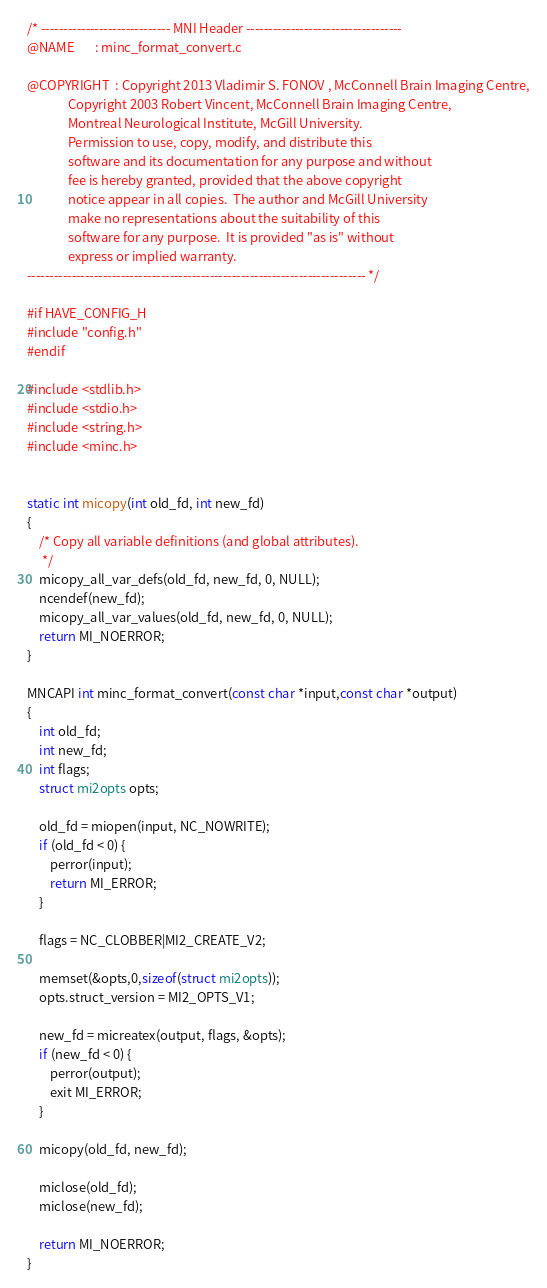Convert code to text. <code><loc_0><loc_0><loc_500><loc_500><_C_>/* ----------------------------- MNI Header -----------------------------------
@NAME       : minc_format_convert.c

@COPYRIGHT  : Copyright 2013 Vladimir S. FONOV , McConnell Brain Imaging Centre,
              Copyright 2003 Robert Vincent, McConnell Brain Imaging Centre, 
              Montreal Neurological Institute, McGill University.
              Permission to use, copy, modify, and distribute this
              software and its documentation for any purpose and without
              fee is hereby granted, provided that the above copyright
              notice appear in all copies.  The author and McGill University
              make no representations about the suitability of this
              software for any purpose.  It is provided "as is" without
              express or implied warranty.
---------------------------------------------------------------------------- */

#if HAVE_CONFIG_H
#include "config.h"
#endif

#include <stdlib.h>
#include <stdio.h>
#include <string.h>
#include <minc.h>


static int micopy(int old_fd, int new_fd)
{
    /* Copy all variable definitions (and global attributes).
     */
    micopy_all_var_defs(old_fd, new_fd, 0, NULL);
    ncendef(new_fd);
    micopy_all_var_values(old_fd, new_fd, 0, NULL);
    return MI_NOERROR;
}

MNCAPI int minc_format_convert(const char *input,const char *output)
{
    int old_fd;
    int new_fd;
    int flags;
    struct mi2opts opts;
    
    old_fd = miopen(input, NC_NOWRITE);
    if (old_fd < 0) {
        perror(input);
        return MI_ERROR;
    }

    flags = NC_CLOBBER|MI2_CREATE_V2;

    memset(&opts,0,sizeof(struct mi2opts));
    opts.struct_version = MI2_OPTS_V1;

    new_fd = micreatex(output, flags, &opts);
    if (new_fd < 0) {
        perror(output);
        exit MI_ERROR;
    }

    micopy(old_fd, new_fd);

    miclose(old_fd);
    miclose(new_fd);
    
    return MI_NOERROR;
}
</code> 